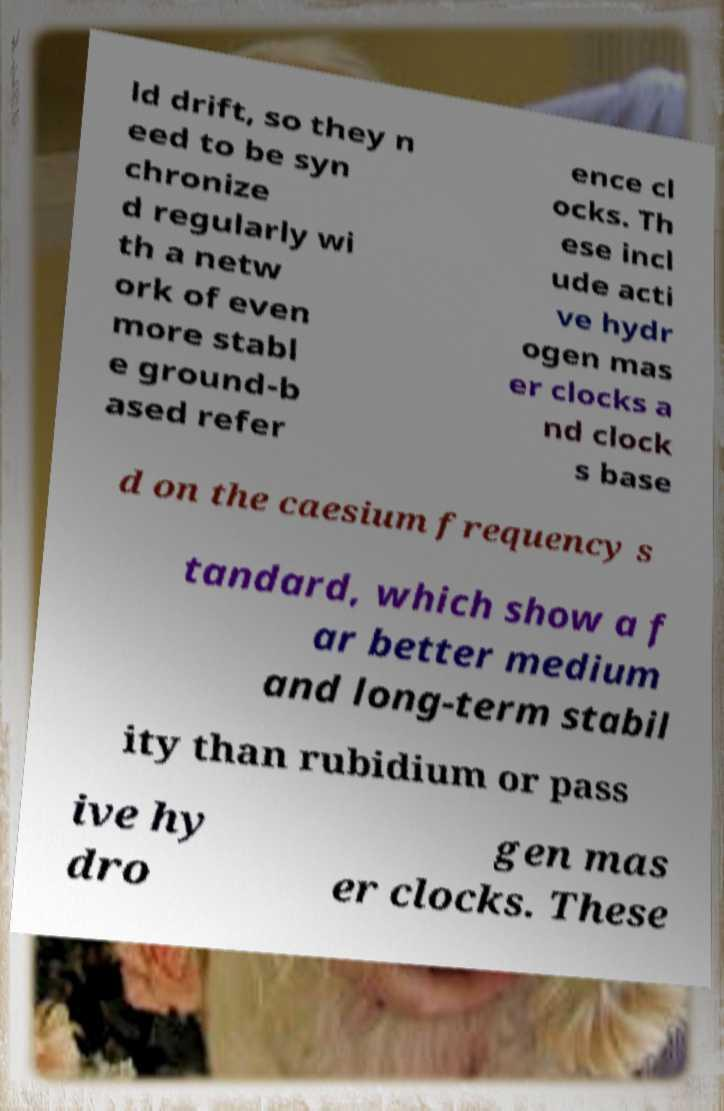Could you extract and type out the text from this image? ld drift, so they n eed to be syn chronize d regularly wi th a netw ork of even more stabl e ground-b ased refer ence cl ocks. Th ese incl ude acti ve hydr ogen mas er clocks a nd clock s base d on the caesium frequency s tandard, which show a f ar better medium and long-term stabil ity than rubidium or pass ive hy dro gen mas er clocks. These 